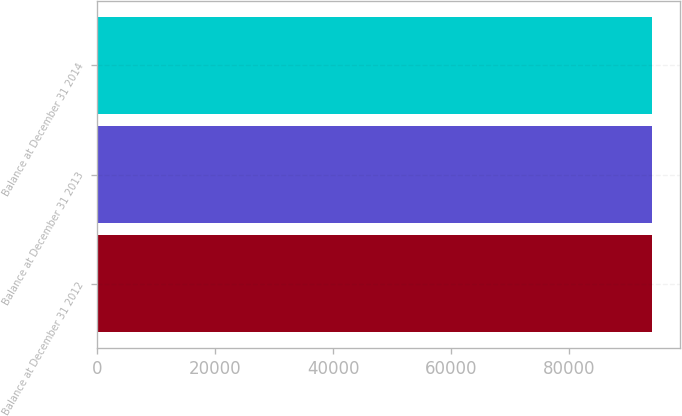<chart> <loc_0><loc_0><loc_500><loc_500><bar_chart><fcel>Balance at December 31 2012<fcel>Balance at December 31 2013<fcel>Balance at December 31 2014<nl><fcel>94000<fcel>94000.1<fcel>94000.2<nl></chart> 